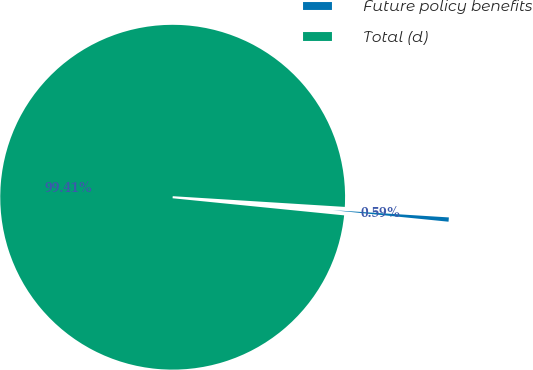<chart> <loc_0><loc_0><loc_500><loc_500><pie_chart><fcel>Future policy benefits<fcel>Total (d)<nl><fcel>0.59%<fcel>99.41%<nl></chart> 